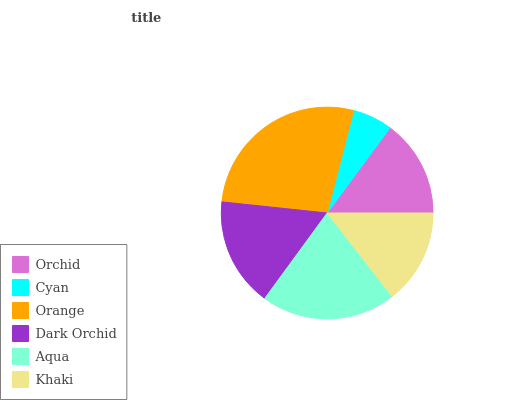Is Cyan the minimum?
Answer yes or no. Yes. Is Orange the maximum?
Answer yes or no. Yes. Is Orange the minimum?
Answer yes or no. No. Is Cyan the maximum?
Answer yes or no. No. Is Orange greater than Cyan?
Answer yes or no. Yes. Is Cyan less than Orange?
Answer yes or no. Yes. Is Cyan greater than Orange?
Answer yes or no. No. Is Orange less than Cyan?
Answer yes or no. No. Is Dark Orchid the high median?
Answer yes or no. Yes. Is Orchid the low median?
Answer yes or no. Yes. Is Orchid the high median?
Answer yes or no. No. Is Orange the low median?
Answer yes or no. No. 